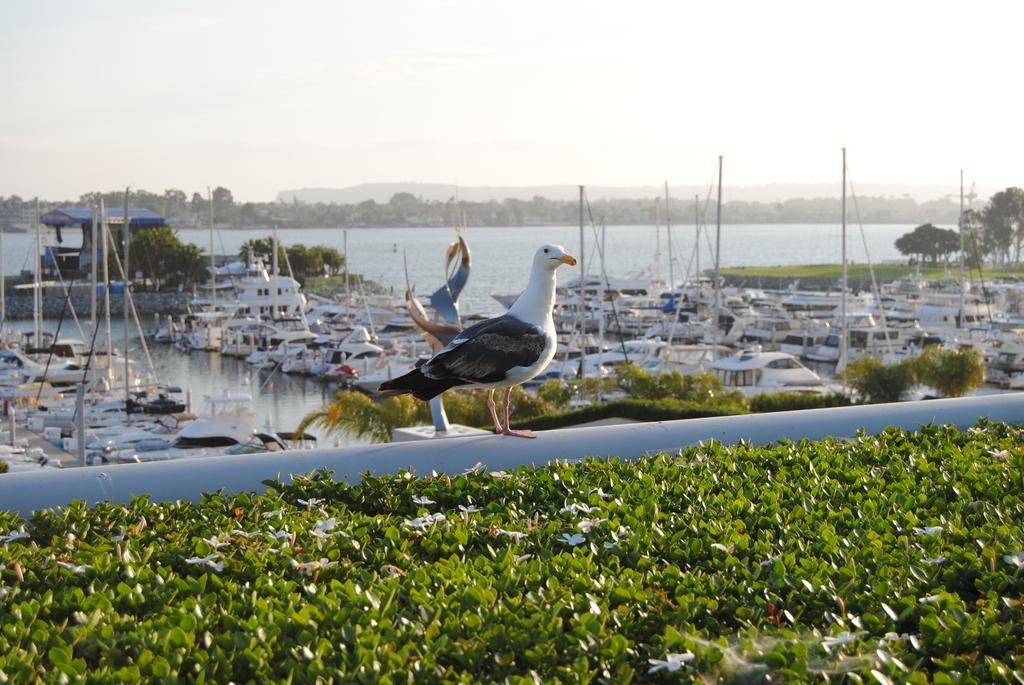How would you summarize this image in a sentence or two? In this picture I can see few plants in front and I can see a bird on the white color thing. In the middle of this picture I can see the water, on which there are number of boats and I can see number of trees. In the background I can see the sky. 